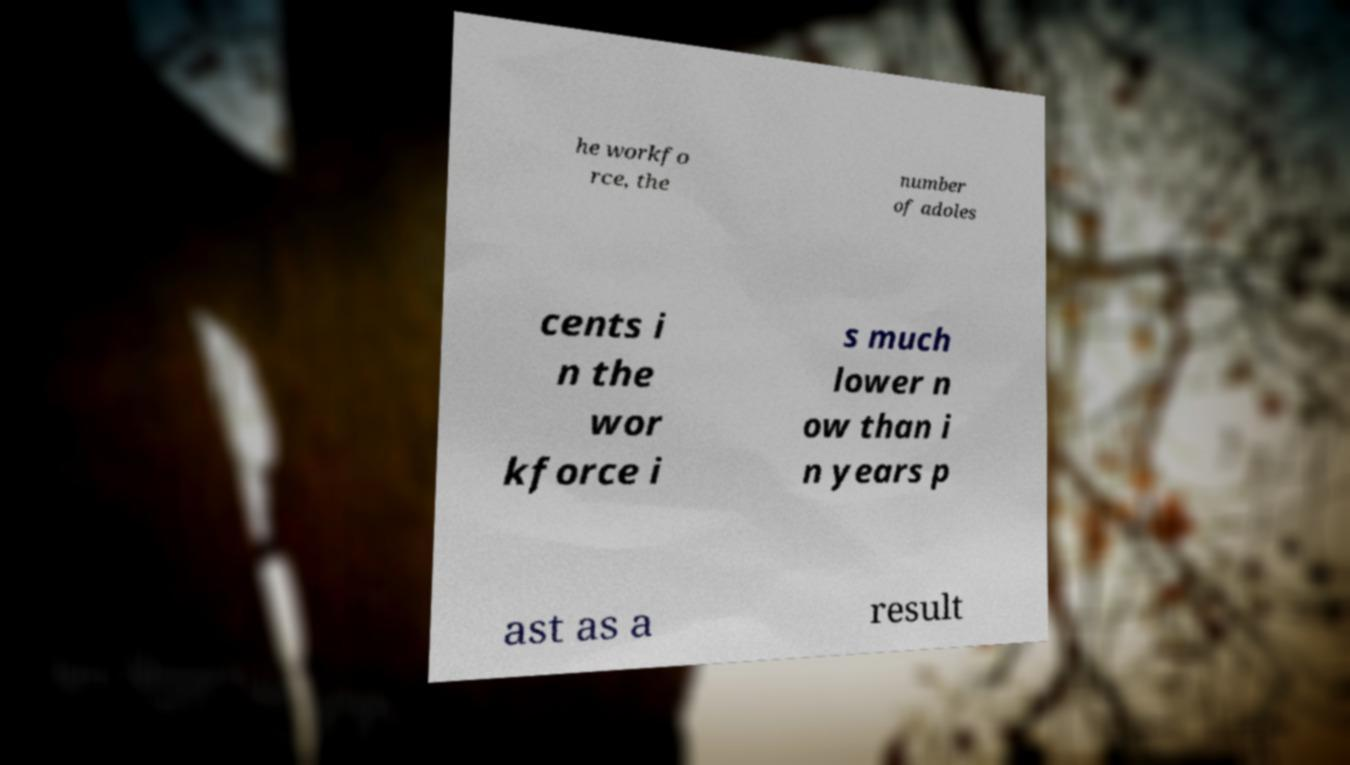Can you read and provide the text displayed in the image?This photo seems to have some interesting text. Can you extract and type it out for me? he workfo rce, the number of adoles cents i n the wor kforce i s much lower n ow than i n years p ast as a result 